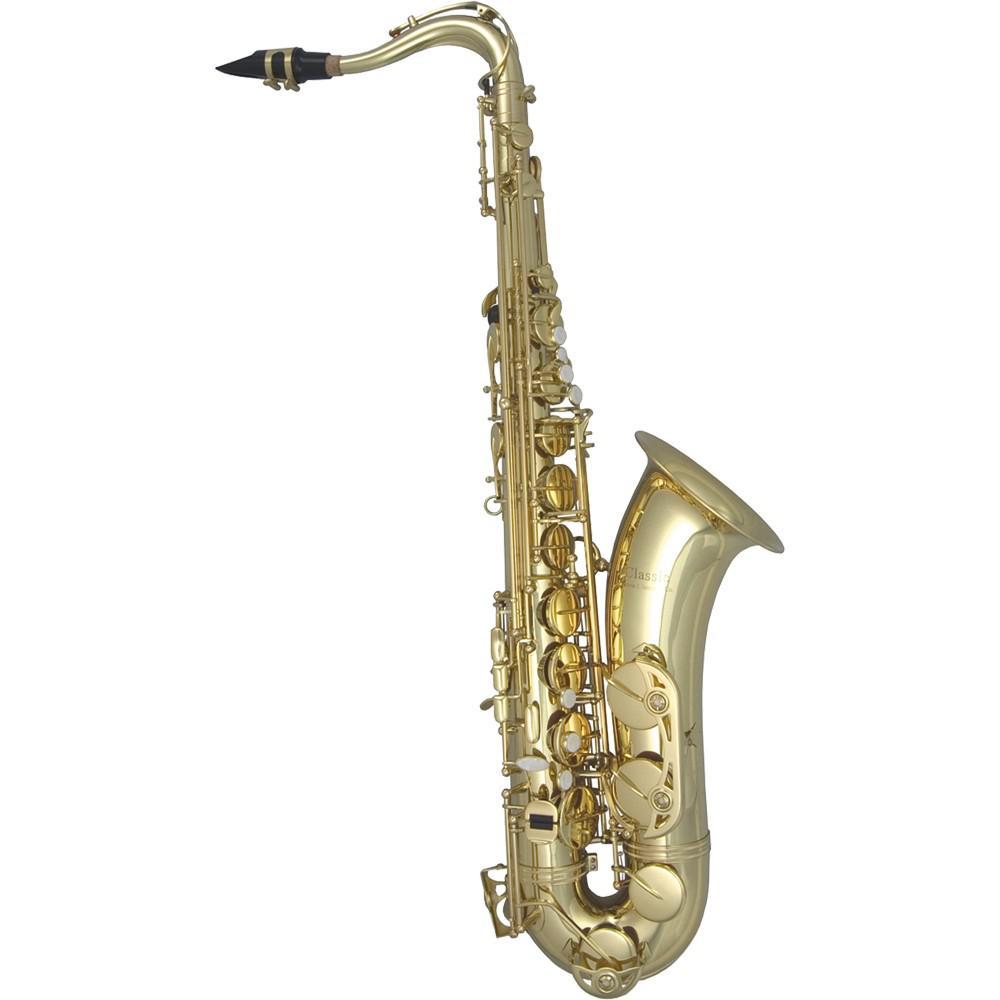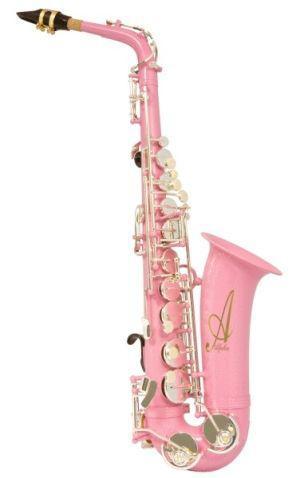The first image is the image on the left, the second image is the image on the right. Assess this claim about the two images: "Exactly two saxophones are the same size and positioned at the same angle, but are different colors.". Correct or not? Answer yes or no. Yes. The first image is the image on the left, the second image is the image on the right. Given the left and right images, does the statement "One saxophone has a traditional metallic colored body, and the other has a body colored some shade of pink." hold true? Answer yes or no. Yes. 